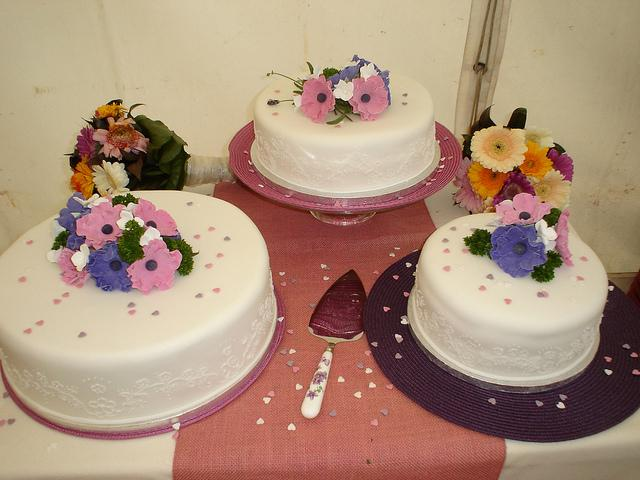What time of icing is on all of the cakes? Please explain your reasoning. vanilla. The icing is all white. 